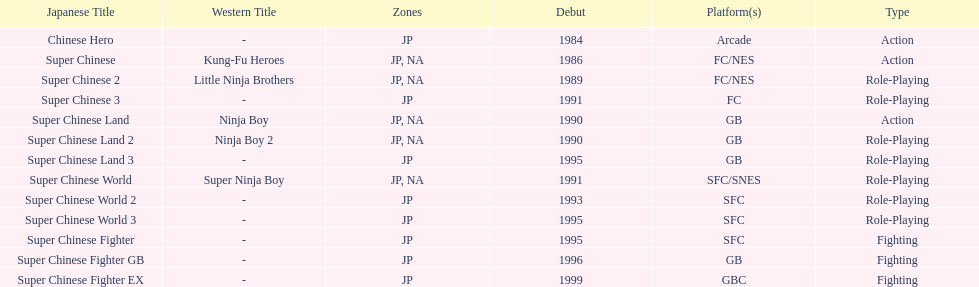Which titles were released in north america? Super Chinese, Super Chinese 2, Super Chinese Land, Super Chinese Land 2, Super Chinese World. Of those, which had the least releases? Super Chinese World. 